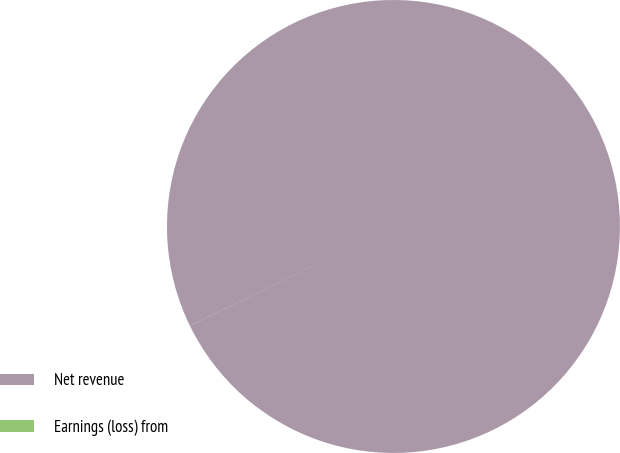Convert chart to OTSL. <chart><loc_0><loc_0><loc_500><loc_500><pie_chart><fcel>Net revenue<fcel>Earnings (loss) from<nl><fcel>99.99%<fcel>0.01%<nl></chart> 